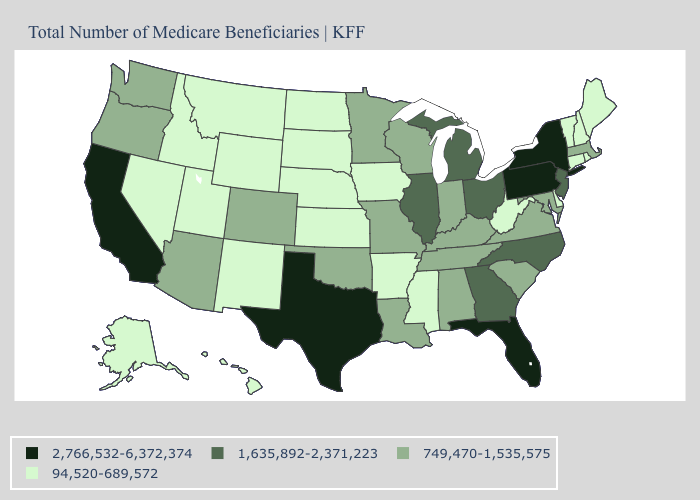What is the value of Arizona?
Short answer required. 749,470-1,535,575. What is the lowest value in the Northeast?
Concise answer only. 94,520-689,572. What is the value of Kentucky?
Concise answer only. 749,470-1,535,575. What is the value of North Carolina?
Quick response, please. 1,635,892-2,371,223. What is the lowest value in the USA?
Quick response, please. 94,520-689,572. What is the value of Connecticut?
Short answer required. 94,520-689,572. Does Texas have the highest value in the USA?
Keep it brief. Yes. Does West Virginia have the lowest value in the USA?
Short answer required. Yes. Does Oregon have the same value as Washington?
Concise answer only. Yes. Does the first symbol in the legend represent the smallest category?
Write a very short answer. No. Does North Carolina have the same value as Ohio?
Concise answer only. Yes. What is the lowest value in the USA?
Keep it brief. 94,520-689,572. Is the legend a continuous bar?
Answer briefly. No. Name the states that have a value in the range 749,470-1,535,575?
Keep it brief. Alabama, Arizona, Colorado, Indiana, Kentucky, Louisiana, Maryland, Massachusetts, Minnesota, Missouri, Oklahoma, Oregon, South Carolina, Tennessee, Virginia, Washington, Wisconsin. 